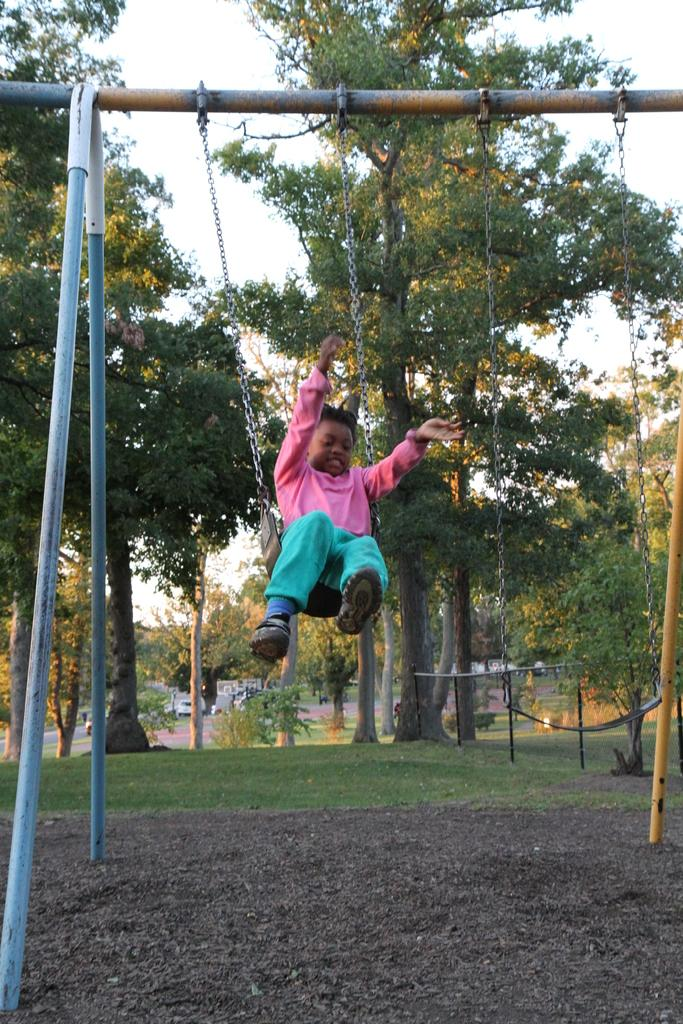What is the person in the image doing? The person is sitting on a swing in the image. What color is the person's shirt? The person is wearing a pink shirt. What color are the person's pants? The person is wearing green pants. What can be seen in the background of the image? There are trees and the sky visible in the background of the image. What is the color of the trees in the image? The trees are green in the image. What is the color of the sky in the image? The sky is white in color in the image. What route does the person take to express their anger in the image? There is no indication of anger or a specific route in the image; the person is simply sitting on a swing. 